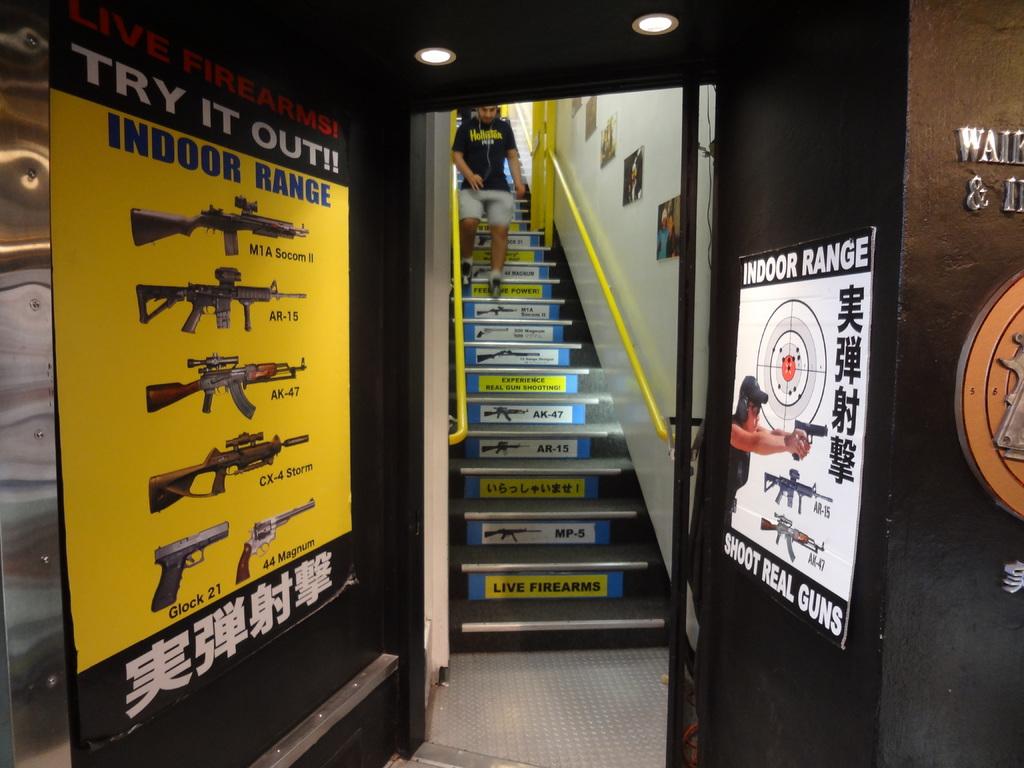What caliber is the revolver in the poster?
Your answer should be very brief. 44 magnum. 